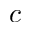Convert formula to latex. <formula><loc_0><loc_0><loc_500><loc_500>c</formula> 